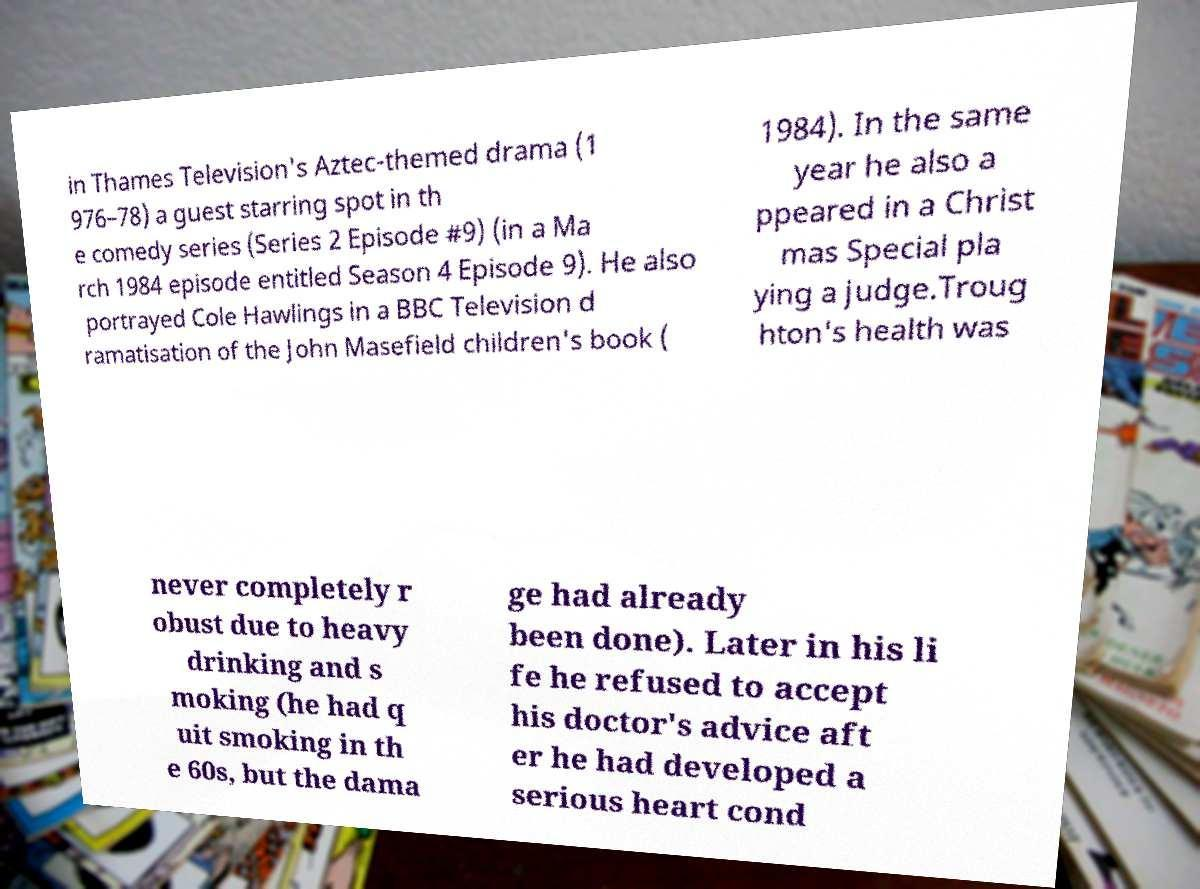Please read and relay the text visible in this image. What does it say? in Thames Television's Aztec-themed drama (1 976–78) a guest starring spot in th e comedy series (Series 2 Episode #9) (in a Ma rch 1984 episode entitled Season 4 Episode 9). He also portrayed Cole Hawlings in a BBC Television d ramatisation of the John Masefield children's book ( 1984). In the same year he also a ppeared in a Christ mas Special pla ying a judge.Troug hton's health was never completely r obust due to heavy drinking and s moking (he had q uit smoking in th e 60s, but the dama ge had already been done). Later in his li fe he refused to accept his doctor's advice aft er he had developed a serious heart cond 